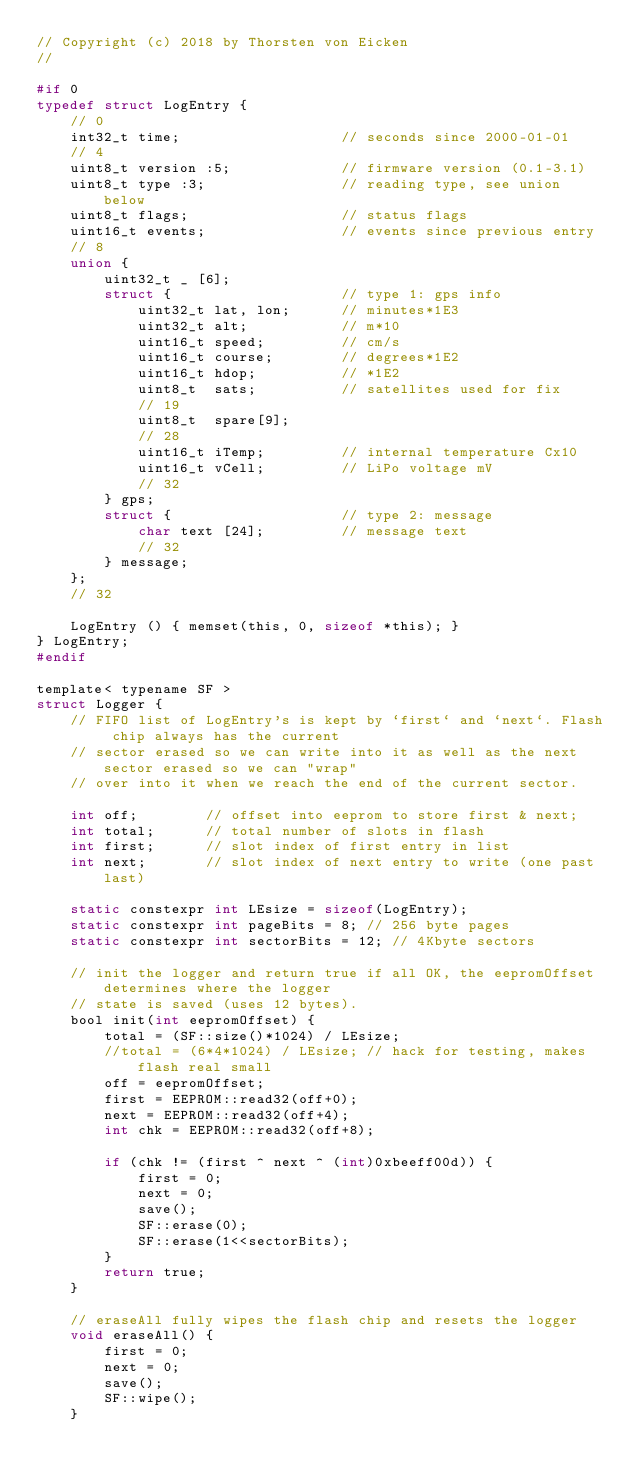<code> <loc_0><loc_0><loc_500><loc_500><_C_>// Copyright (c) 2018 by Thorsten von Eicken
//

#if 0
typedef struct LogEntry {
    // 0
    int32_t time;                   // seconds since 2000-01-01
    // 4
    uint8_t version :5;             // firmware version (0.1-3.1)
    uint8_t type :3;                // reading type, see union below
    uint8_t flags;                  // status flags
    uint16_t events;                // events since previous entry
    // 8
    union {
        uint32_t _ [6];
        struct {                    // type 1: gps info
            uint32_t lat, lon;      // minutes*1E3
            uint32_t alt;           // m*10
            uint16_t speed;         // cm/s
            uint16_t course;        // degrees*1E2
            uint16_t hdop;          // *1E2
            uint8_t  sats;          // satellites used for fix
            // 19
            uint8_t  spare[9];
            // 28
            uint16_t iTemp;         // internal temperature Cx10
            uint16_t vCell;         // LiPo voltage mV
            // 32
        } gps;
        struct {                    // type 2: message
            char text [24];         // message text
            // 32
        } message;
    };
    // 32

    LogEntry () { memset(this, 0, sizeof *this); }
} LogEntry;
#endif

template< typename SF >
struct Logger {
    // FIFO list of LogEntry's is kept by `first` and `next`. Flash chip always has the current
    // sector erased so we can write into it as well as the next sector erased so we can "wrap"
    // over into it when we reach the end of the current sector.

    int off;        // offset into eeprom to store first & next;
    int total;      // total number of slots in flash
    int first;      // slot index of first entry in list
    int next;       // slot index of next entry to write (one past last)

    static constexpr int LEsize = sizeof(LogEntry);
    static constexpr int pageBits = 8; // 256 byte pages
    static constexpr int sectorBits = 12; // 4Kbyte sectors

    // init the logger and return true if all OK, the eepromOffset determines where the logger
    // state is saved (uses 12 bytes).
    bool init(int eepromOffset) {
        total = (SF::size()*1024) / LEsize;
        //total = (6*4*1024) / LEsize; // hack for testing, makes flash real small
        off = eepromOffset;
        first = EEPROM::read32(off+0);
        next = EEPROM::read32(off+4);
        int chk = EEPROM::read32(off+8);

        if (chk != (first ^ next ^ (int)0xbeeff00d)) {
            first = 0;
            next = 0;
            save();
            SF::erase(0);
            SF::erase(1<<sectorBits);
        }
        return true;
    }

    // eraseAll fully wipes the flash chip and resets the logger
    void eraseAll() {
        first = 0;
        next = 0;
        save();
        SF::wipe();
    }
</code> 